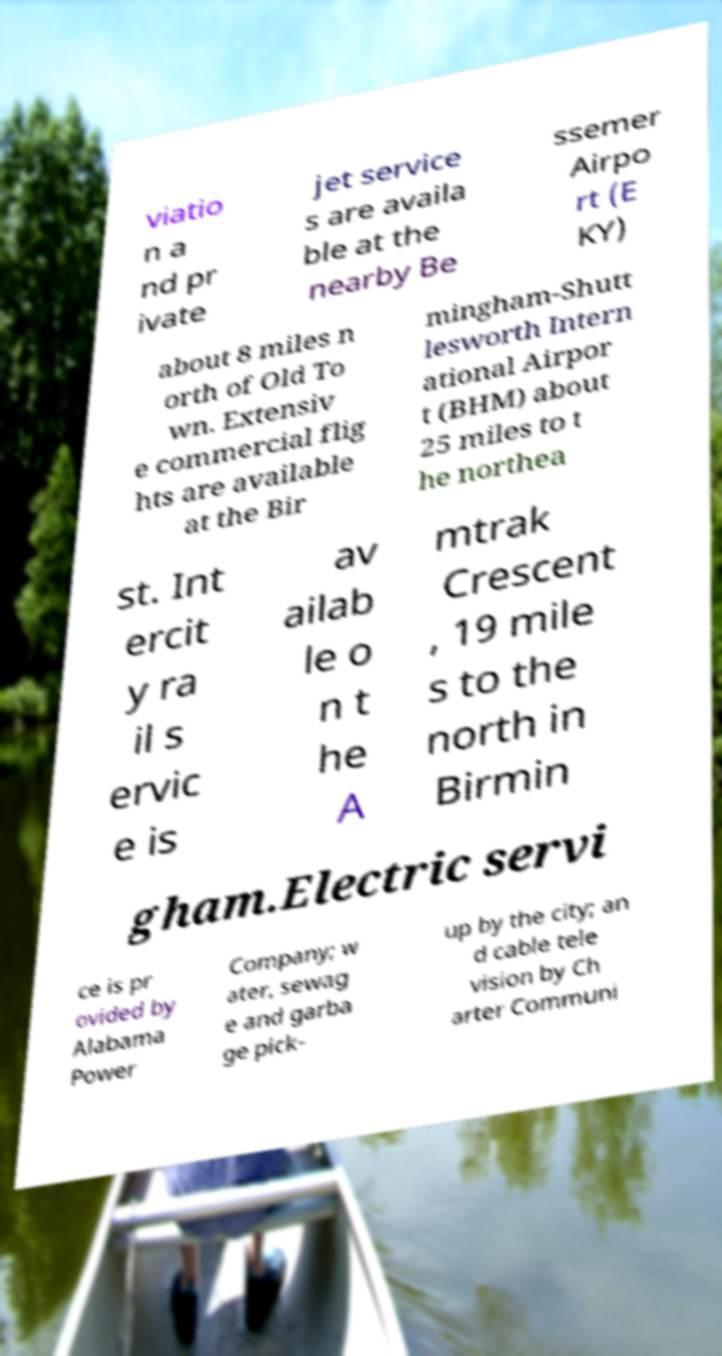There's text embedded in this image that I need extracted. Can you transcribe it verbatim? viatio n a nd pr ivate jet service s are availa ble at the nearby Be ssemer Airpo rt (E KY) about 8 miles n orth of Old To wn. Extensiv e commercial flig hts are available at the Bir mingham-Shutt lesworth Intern ational Airpor t (BHM) about 25 miles to t he northea st. Int ercit y ra il s ervic e is av ailab le o n t he A mtrak Crescent , 19 mile s to the north in Birmin gham.Electric servi ce is pr ovided by Alabama Power Company; w ater, sewag e and garba ge pick- up by the city; an d cable tele vision by Ch arter Communi 